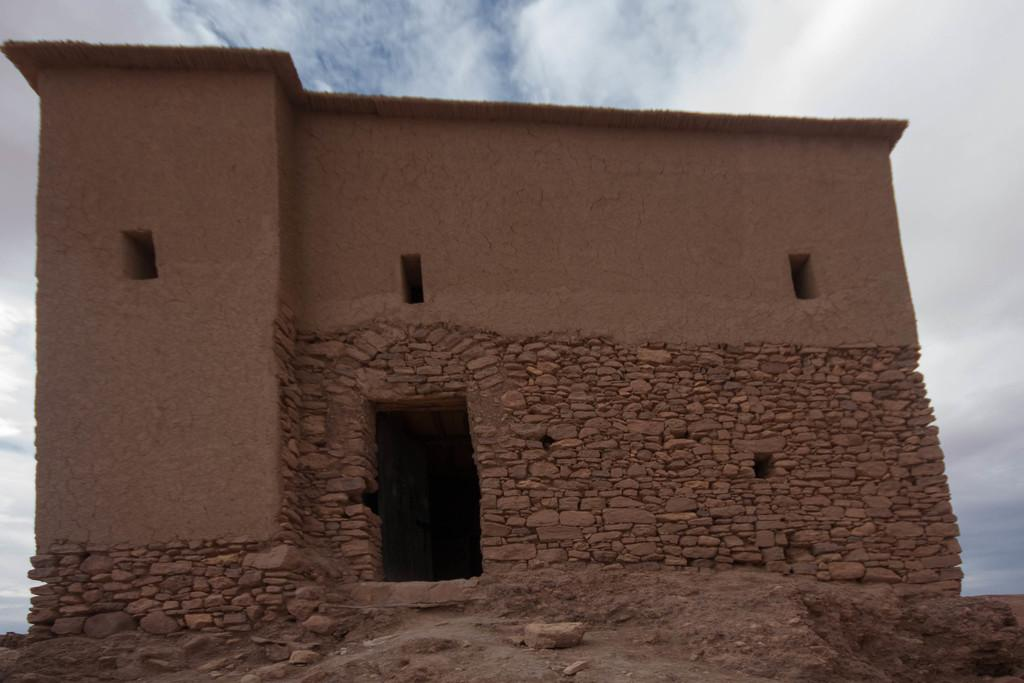What type of structure is present in the image? There is a building in the image. What material was used to construct the building? The building is built with cobblestones. What can be seen in the background of the image? The sky is visible in the background of the image. What is the condition of the sky in the image? There are clouds in the sky. What type of pain is the building experiencing in the image? Buildings do not experience pain, so this question cannot be answered. What kind of lunch is being served at the building in the image? There is no indication of food or lunch being served in the image. 